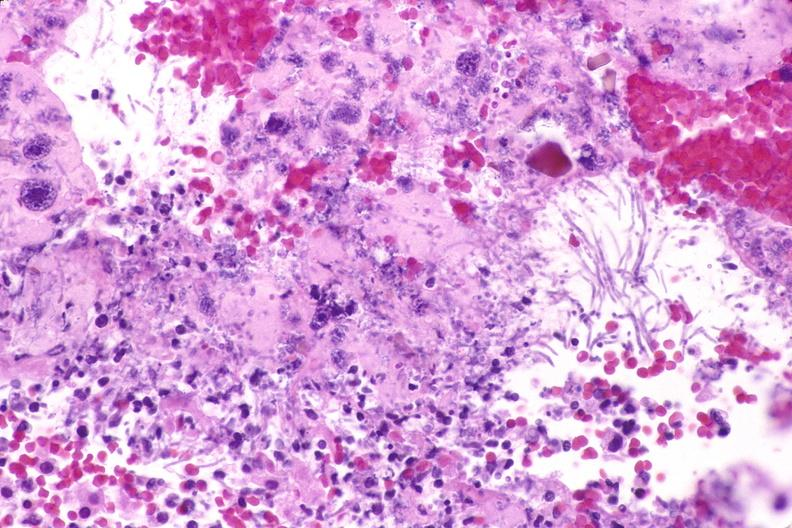what is present?
Answer the question using a single word or phrase. Gastrointestinal 